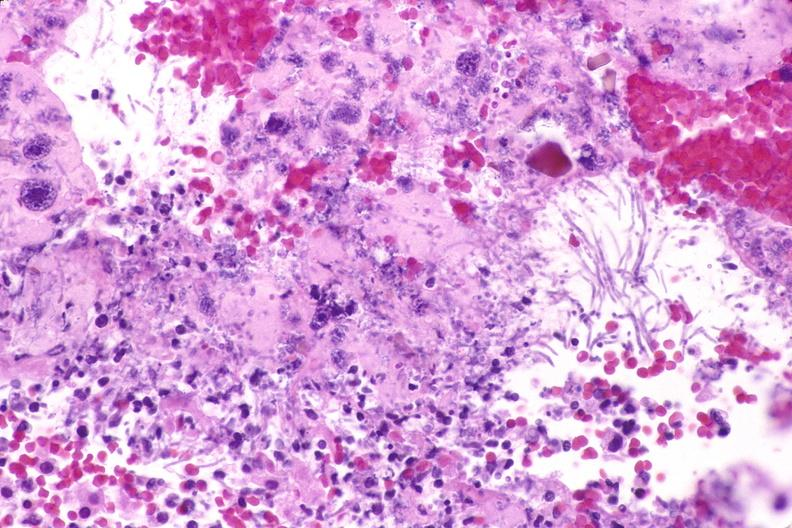what is present?
Answer the question using a single word or phrase. Gastrointestinal 